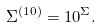Convert formula to latex. <formula><loc_0><loc_0><loc_500><loc_500>\Sigma ^ { ( 1 0 ) } = 1 0 ^ { \Sigma } .</formula> 